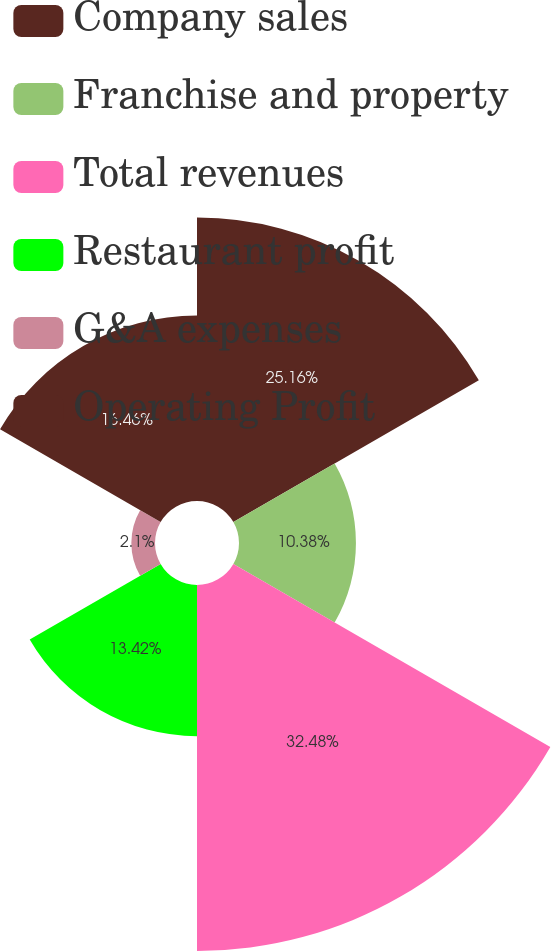Convert chart to OTSL. <chart><loc_0><loc_0><loc_500><loc_500><pie_chart><fcel>Company sales<fcel>Franchise and property<fcel>Total revenues<fcel>Restaurant profit<fcel>G&A expenses<fcel>Operating Profit<nl><fcel>25.16%<fcel>10.38%<fcel>32.49%<fcel>13.42%<fcel>2.1%<fcel>16.46%<nl></chart> 